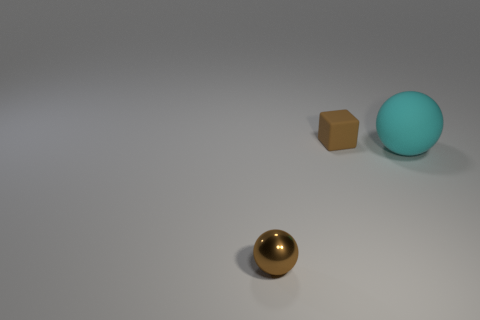Subtract 2 balls. How many balls are left? 0 Subtract all large cyan matte objects. Subtract all brown objects. How many objects are left? 0 Add 2 tiny balls. How many tiny balls are left? 3 Add 2 tiny yellow rubber cylinders. How many tiny yellow rubber cylinders exist? 2 Add 1 cyan matte things. How many objects exist? 4 Subtract 0 yellow cylinders. How many objects are left? 3 Subtract all balls. How many objects are left? 1 Subtract all purple balls. Subtract all cyan cylinders. How many balls are left? 2 Subtract all brown cylinders. How many cyan spheres are left? 1 